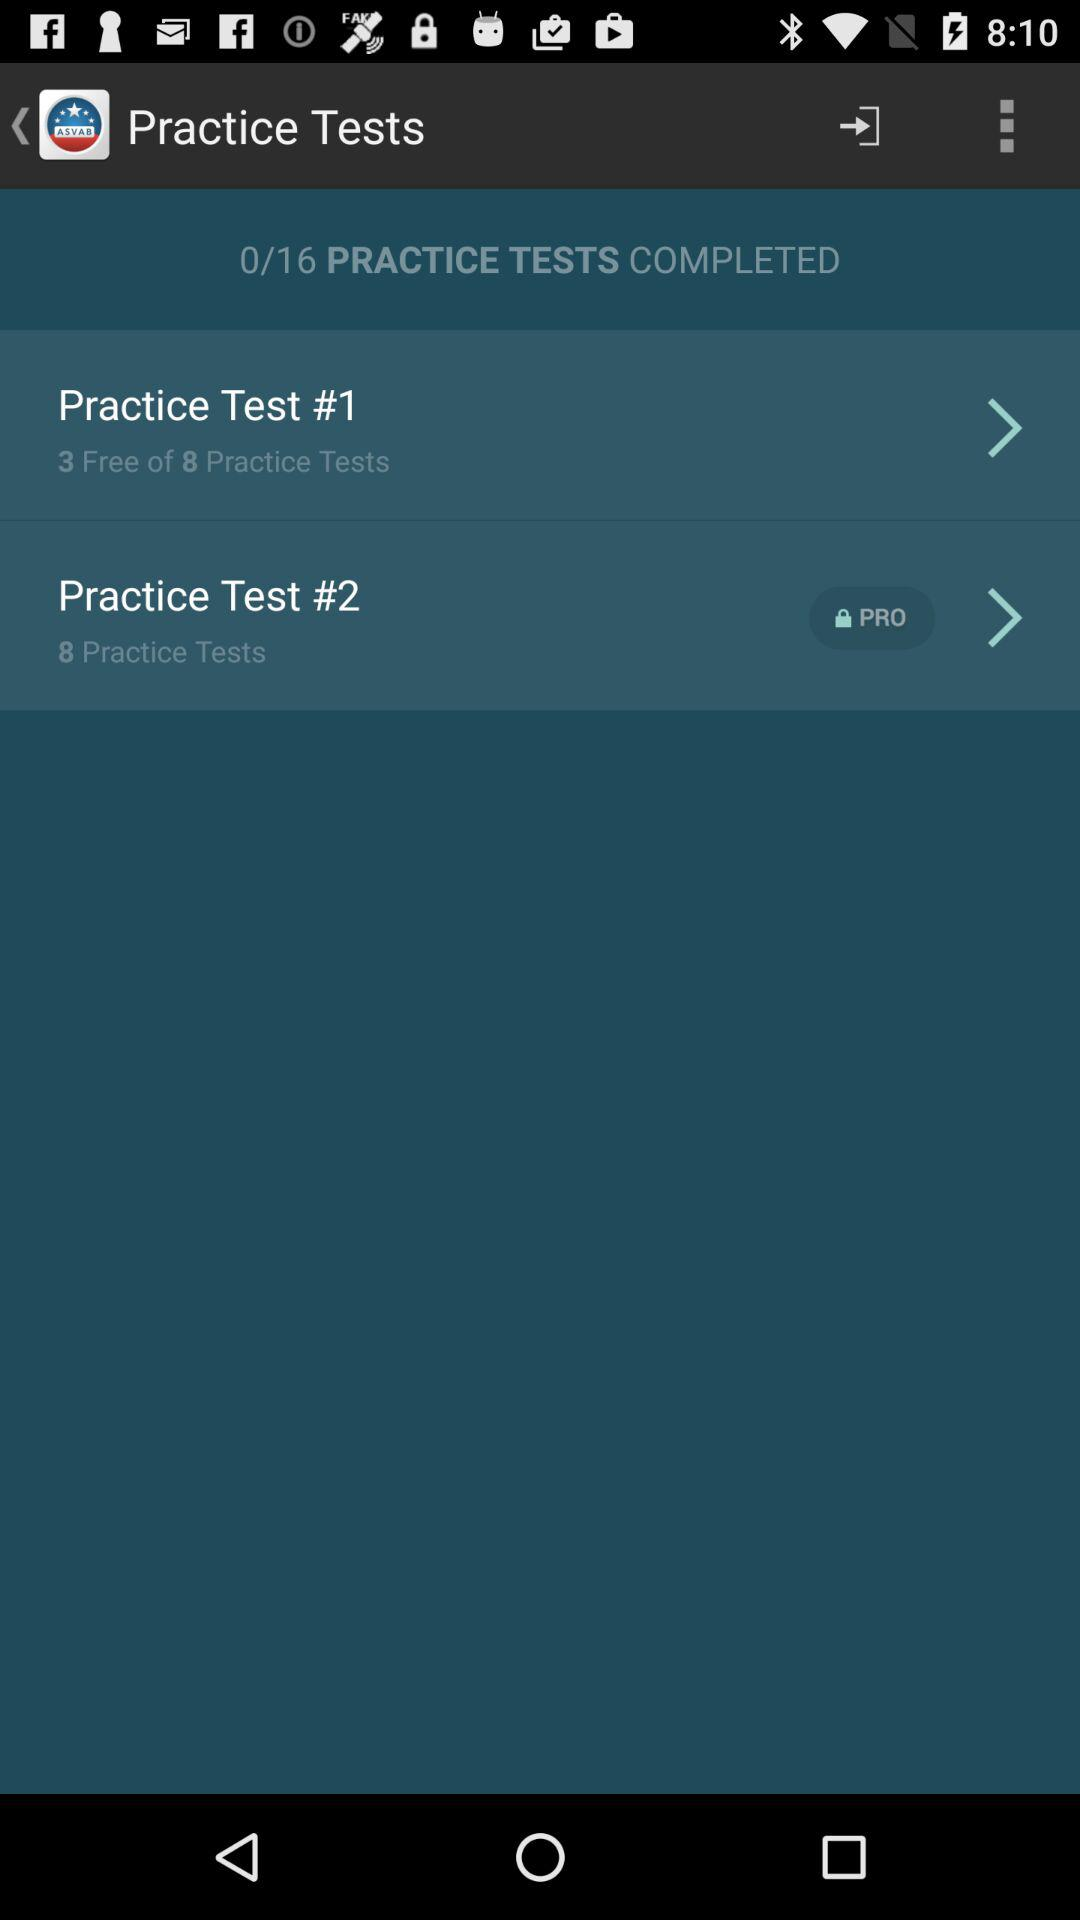How many practice tests are free?
Answer the question using a single word or phrase. 3 